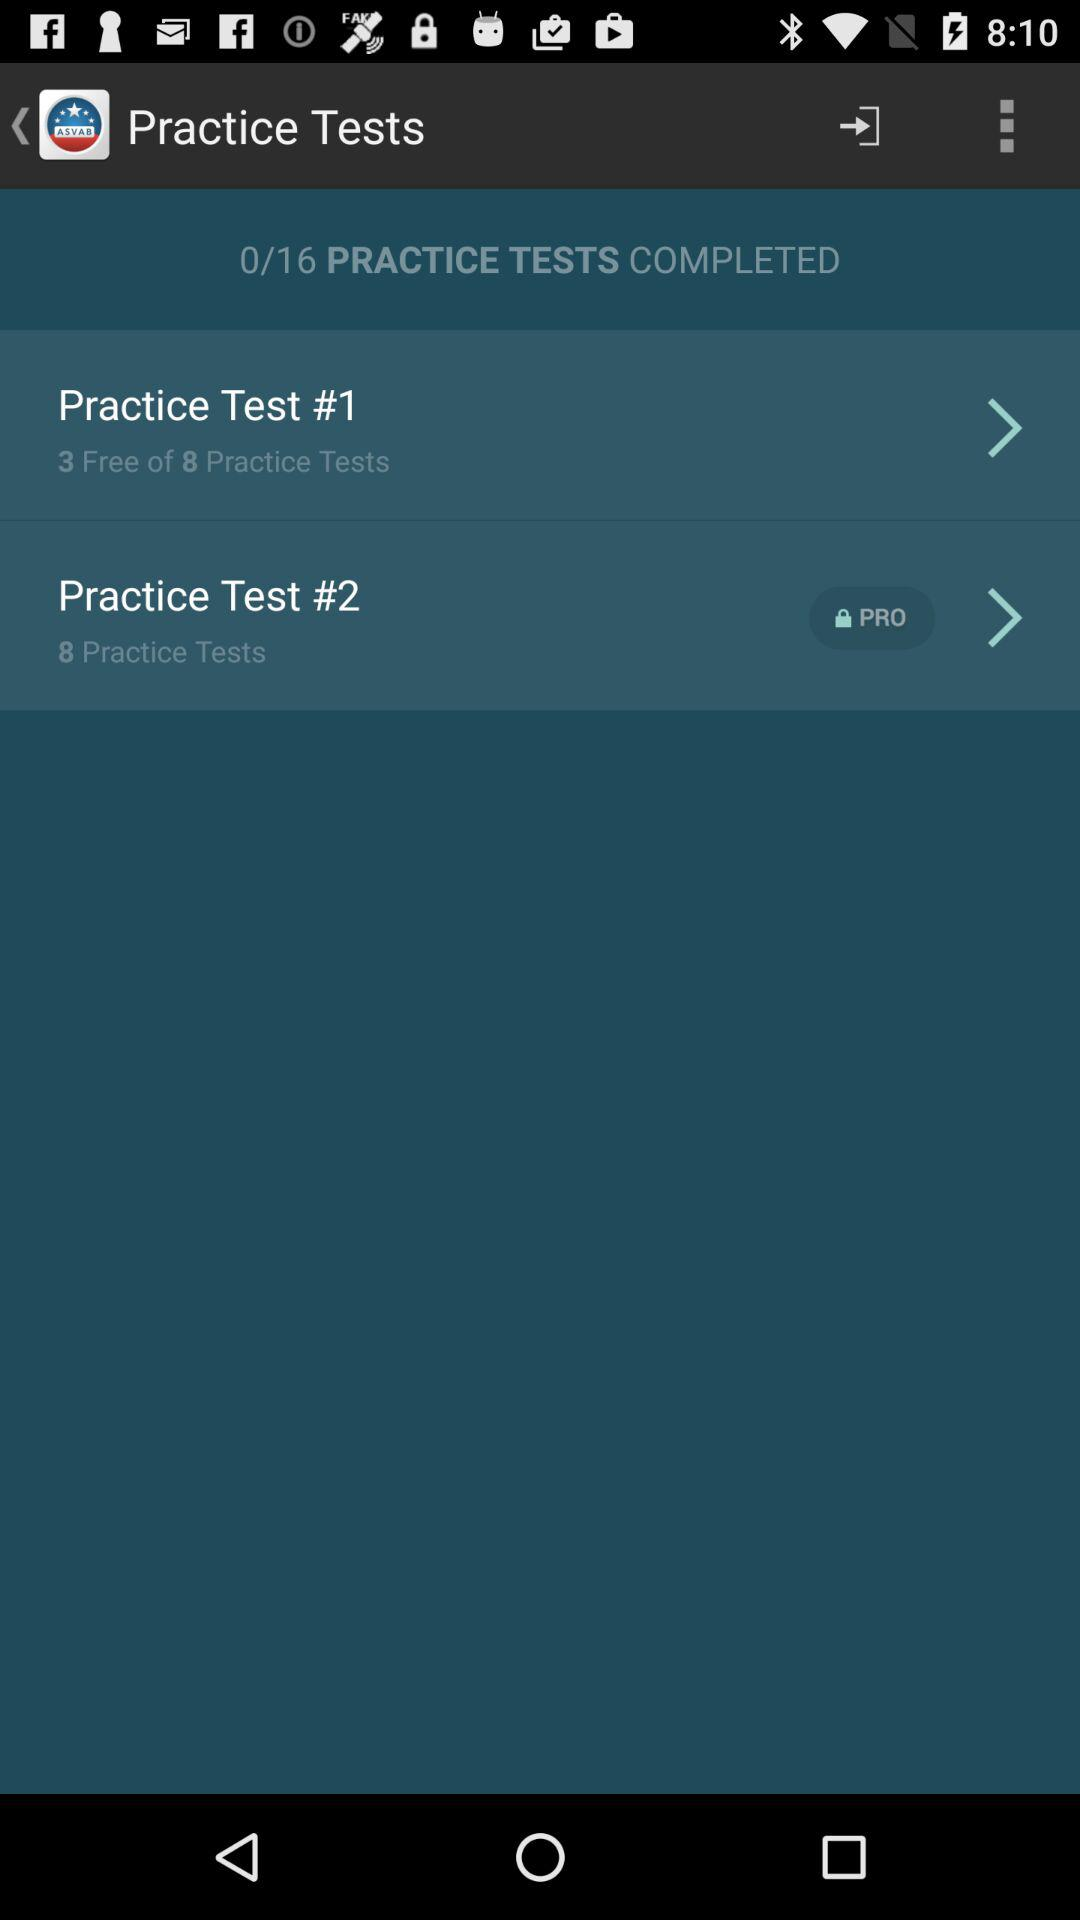How many practice tests are free?
Answer the question using a single word or phrase. 3 